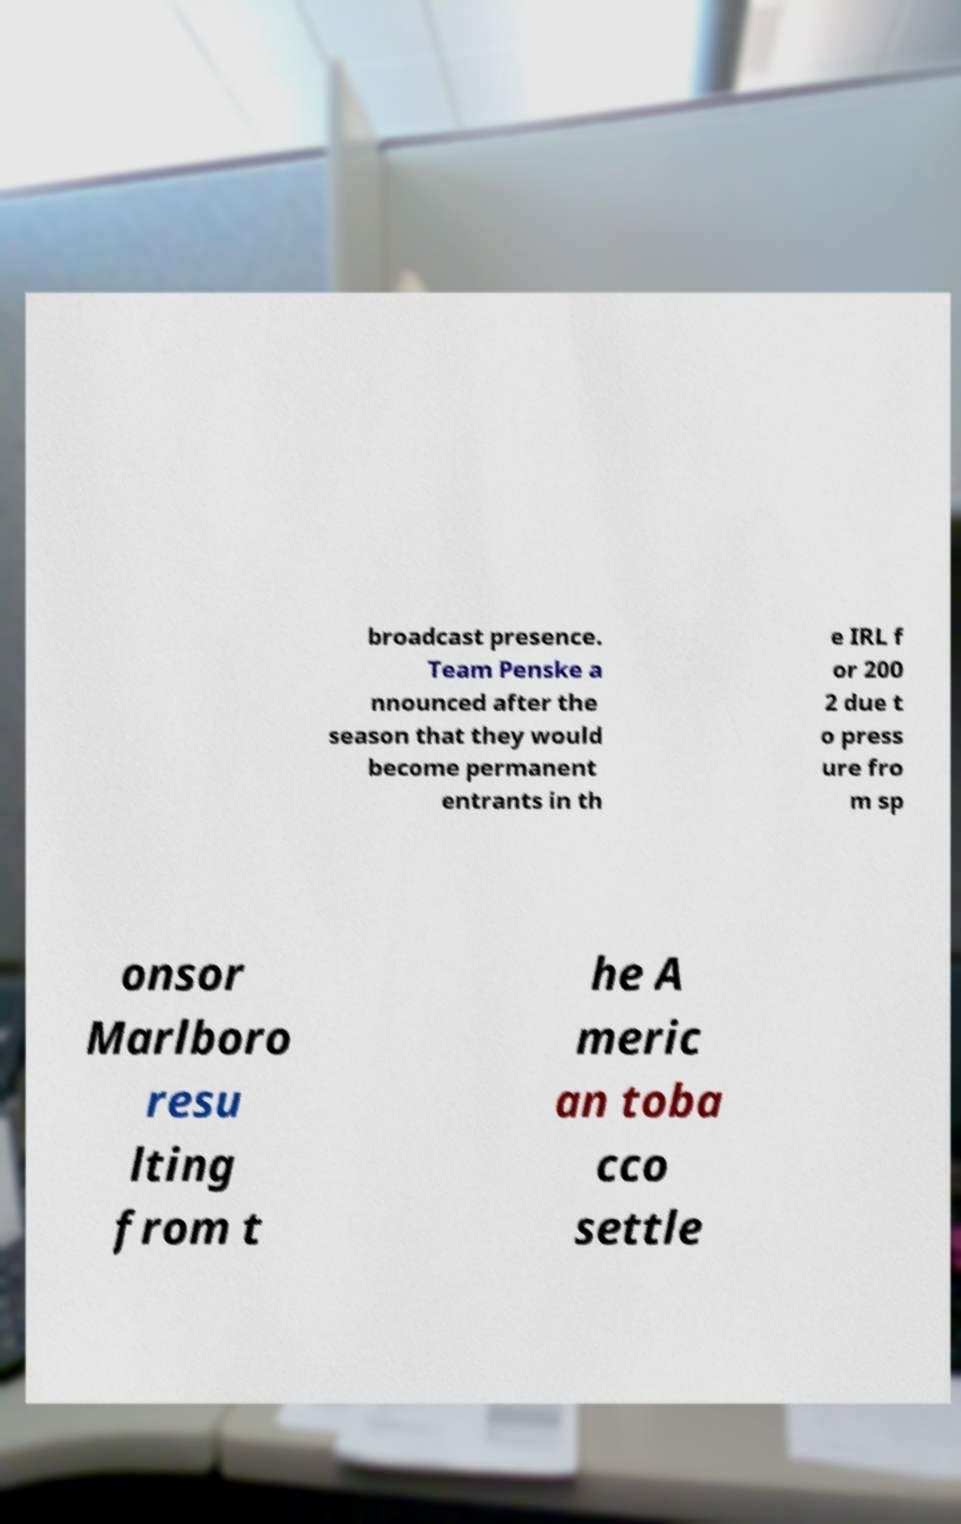Can you read and provide the text displayed in the image?This photo seems to have some interesting text. Can you extract and type it out for me? broadcast presence. Team Penske a nnounced after the season that they would become permanent entrants in th e IRL f or 200 2 due t o press ure fro m sp onsor Marlboro resu lting from t he A meric an toba cco settle 